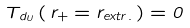<formula> <loc_0><loc_0><loc_500><loc_500>T _ { d _ { U } } \left ( \, r _ { + } = r _ { e x t r . } \, \right ) = 0</formula> 